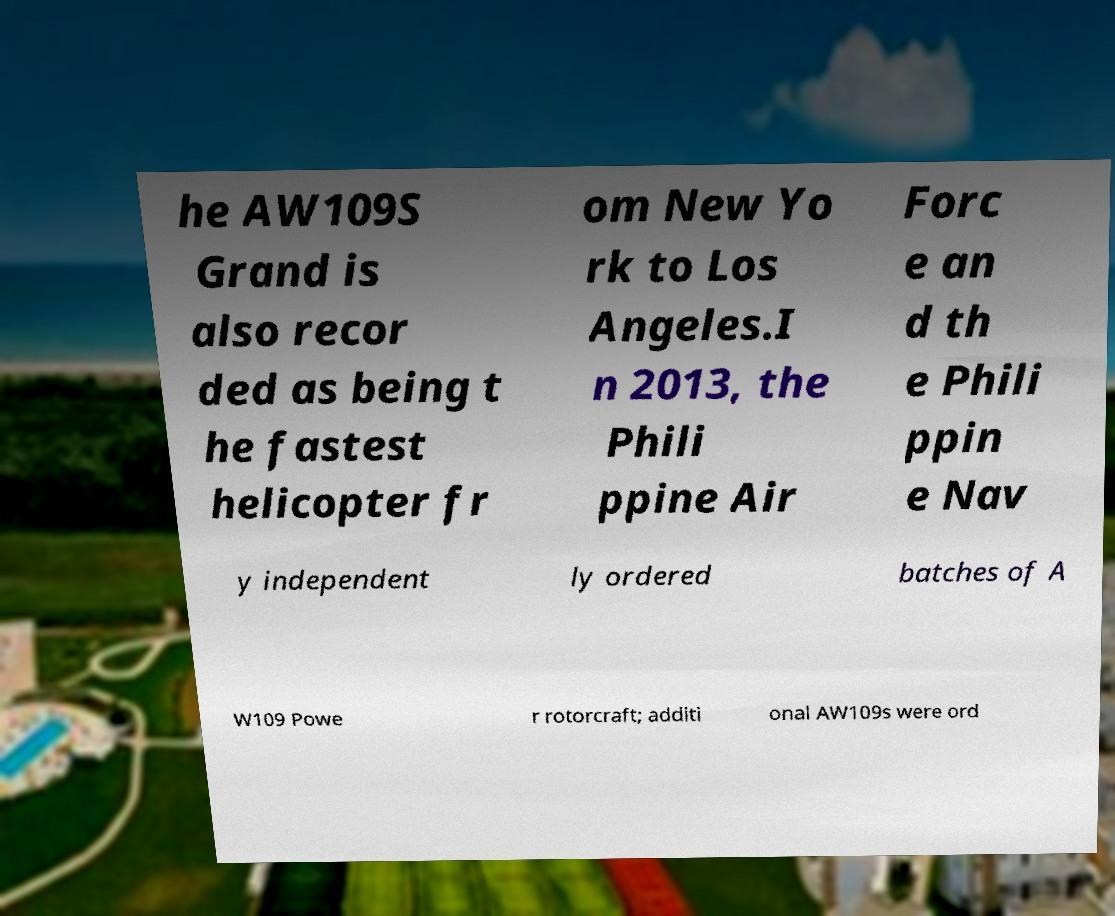Can you accurately transcribe the text from the provided image for me? he AW109S Grand is also recor ded as being t he fastest helicopter fr om New Yo rk to Los Angeles.I n 2013, the Phili ppine Air Forc e an d th e Phili ppin e Nav y independent ly ordered batches of A W109 Powe r rotorcraft; additi onal AW109s were ord 